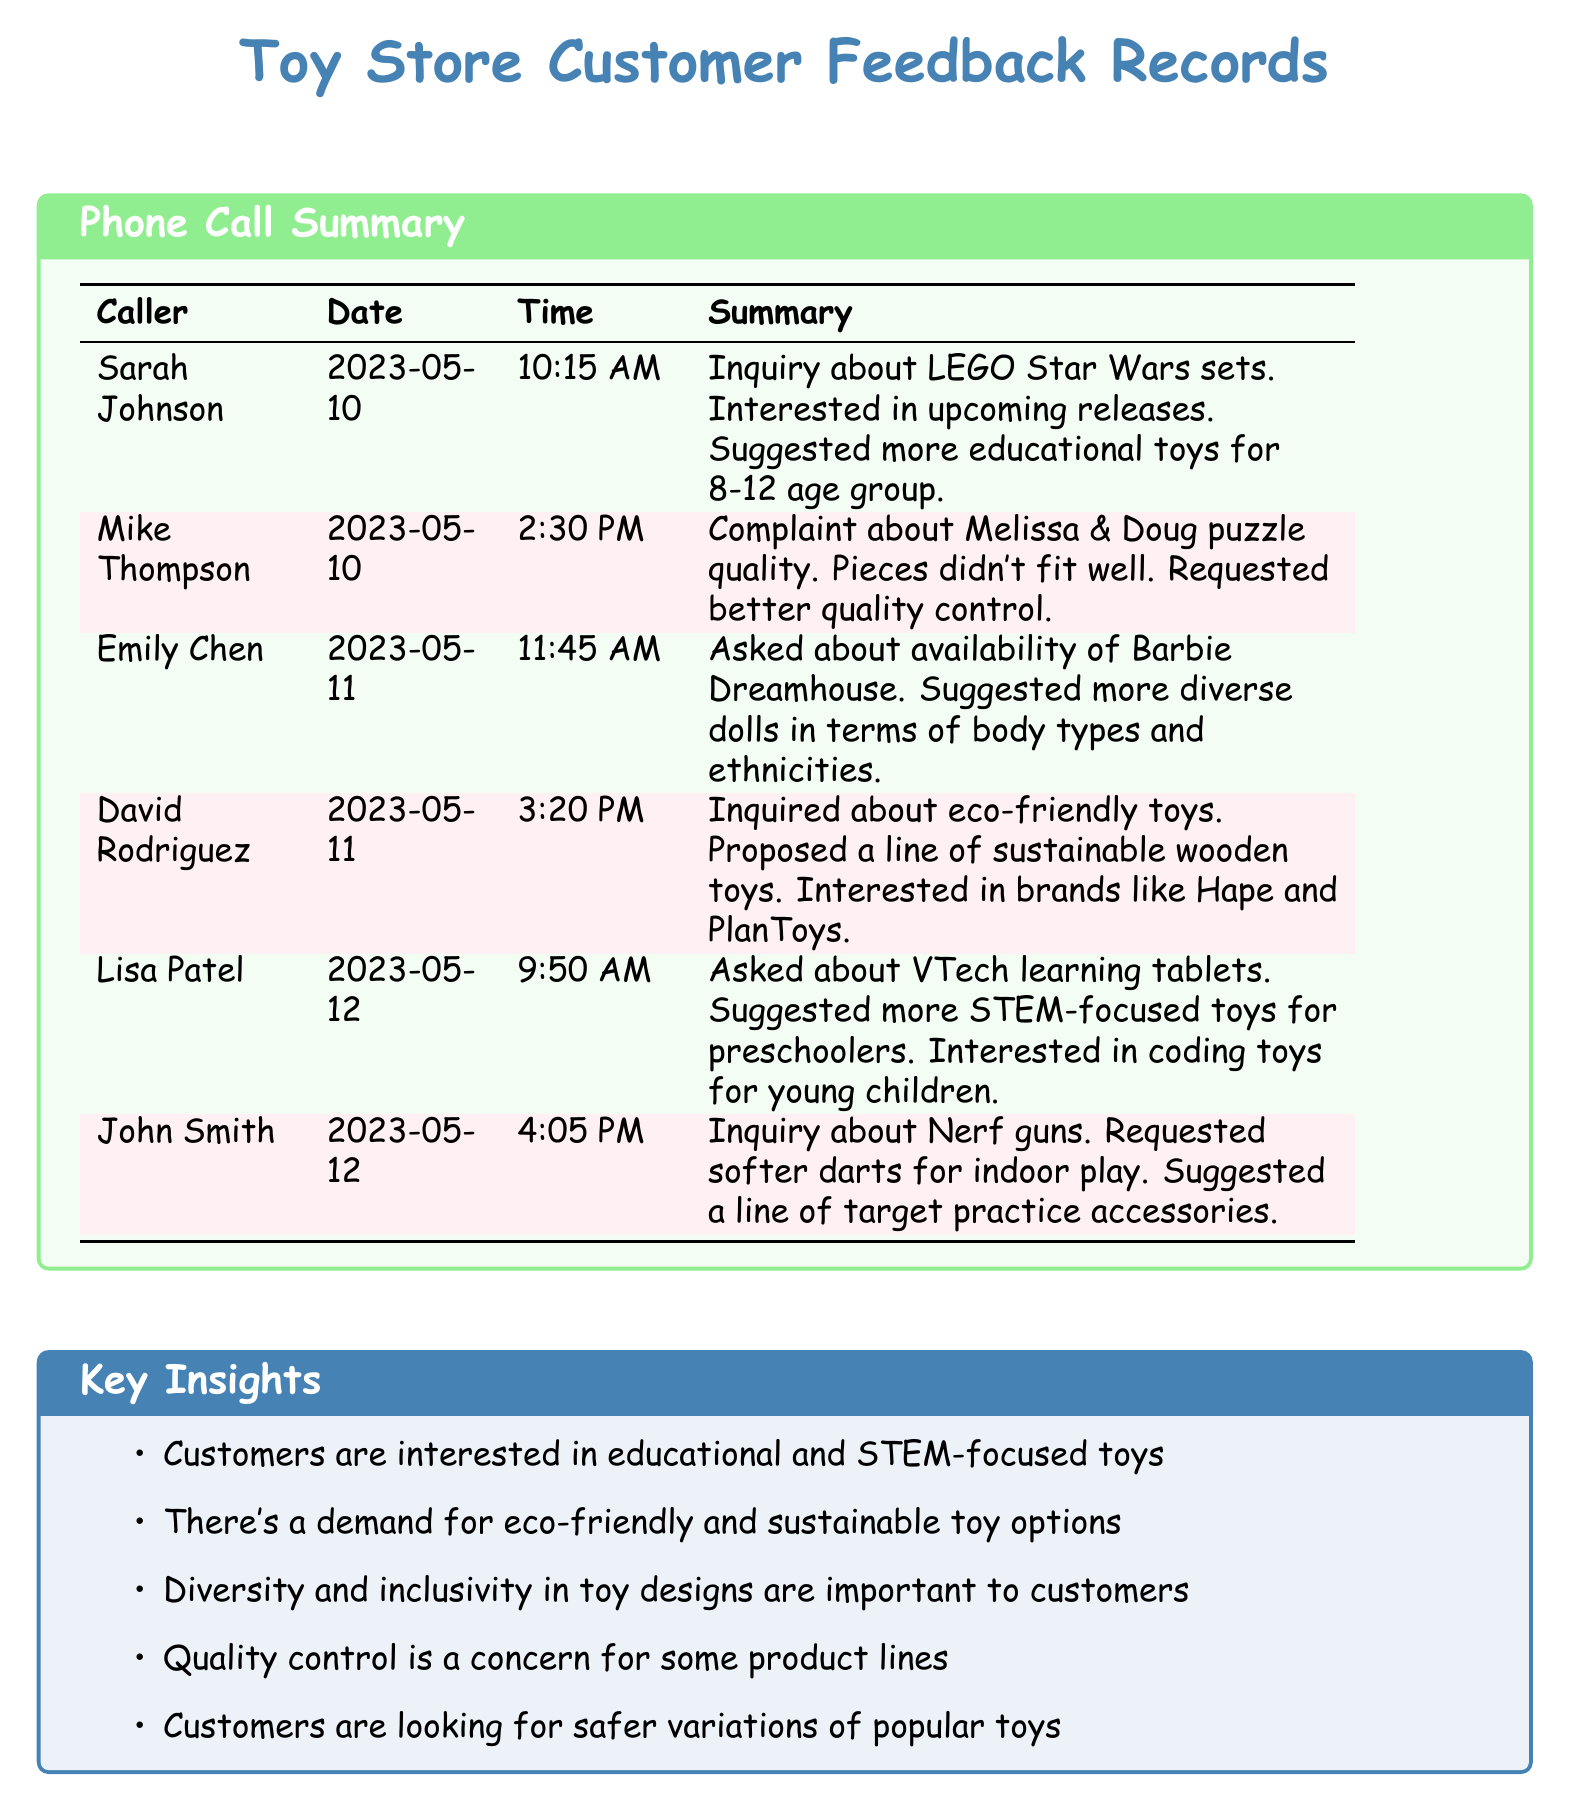What is the name of the caller who inquired about LEGO Star Wars sets? The caller's name is in the first row under the Caller column.
Answer: Sarah Johnson What date did Emily Chen make her call? The date can be found in the row corresponding to Emily Chen.
Answer: 2023-05-11 What time did Mike Thompson make his call? The time is located in the second row under the Time column for Mike Thompson.
Answer: 2:30 PM What product did David Rodriguez inquire about? The product David inquired about is found in his summary in the table.
Answer: eco-friendly toys What suggestion did Lisa Patel make regarding toys? The suggestion is mentioned in the summary of Lisa Patel's call in the table.
Answer: more STEM-focused toys for preschoolers How many calls were made about toy quality issues? Count the rows mentioning quality issues in the summary; one is about Melissa & Doug puzzles.
Answer: 1 What type of toys does John Smith want softer darts for? The type of toys can be found in the summary of John's call in the document.
Answer: Nerf guns What key insight mentions diversity? The key insight points to customer interest in inclusive toy designs; it can be found in the list of key insights.
Answer: Diversity and inclusivity in toy designs are important to customers What was a common request among multiple callers? Review the summaries for requests mentioned by several callers about toy features.
Answer: educational and STEM-focused toys 